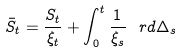Convert formula to latex. <formula><loc_0><loc_0><loc_500><loc_500>\bar { S } _ { t } = \frac { S _ { t } } { \xi _ { t } } + \int _ { 0 } ^ { t } \frac { 1 } { \xi _ { s } } \, \ r d \Delta _ { s }</formula> 